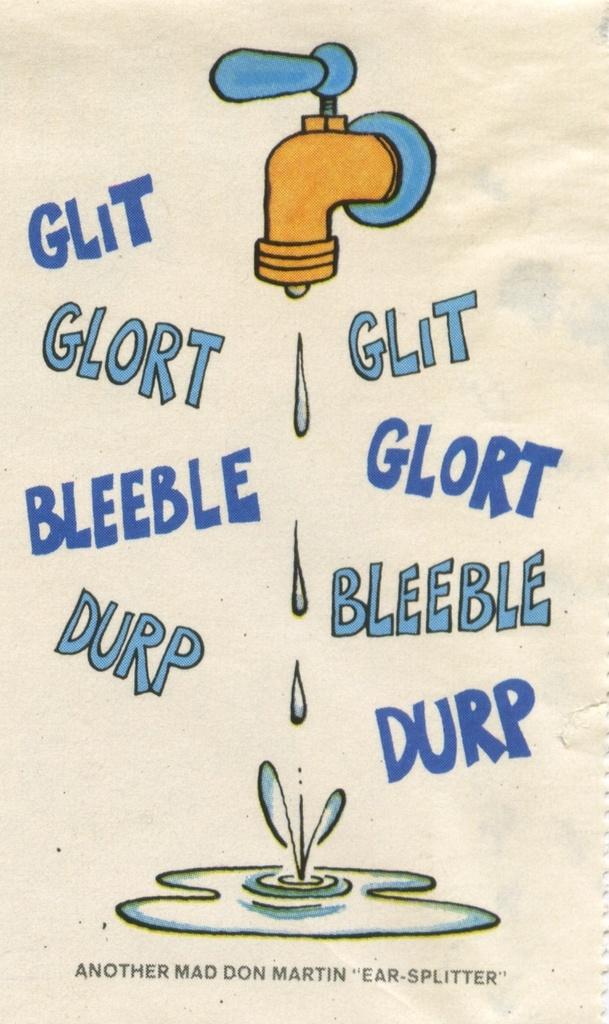Who is mad?
Ensure brevity in your answer.  Don martin. What's the first word in blue can you see?
Offer a terse response. Glit. 